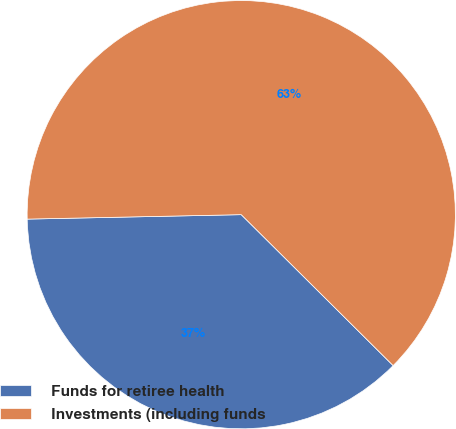Convert chart to OTSL. <chart><loc_0><loc_0><loc_500><loc_500><pie_chart><fcel>Funds for retiree health<fcel>Investments (including funds<nl><fcel>37.22%<fcel>62.78%<nl></chart> 